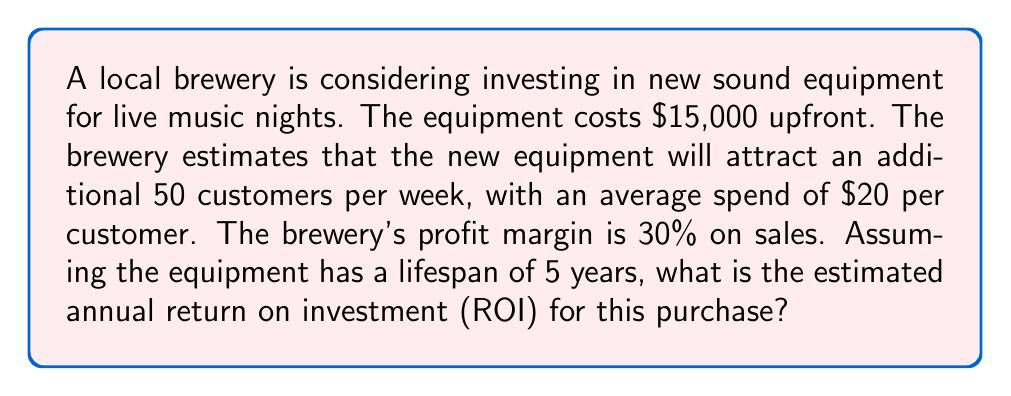Can you answer this question? To calculate the annual ROI, we need to follow these steps:

1. Calculate the additional annual revenue:
   $$ \text{Additional Weekly Revenue} = 50 \text{ customers} \times \$20 = \$1,000 $$
   $$ \text{Additional Annual Revenue} = \$1,000 \times 52 \text{ weeks} = \$52,000 $$

2. Calculate the annual profit from the additional revenue:
   $$ \text{Annual Profit} = \$52,000 \times 30\% = \$15,600 $$

3. Calculate the average annual investment:
   Since the equipment costs $15,000 and lasts for 5 years, the average annual investment is:
   $$ \text{Average Annual Investment} = \frac{\$15,000}{5 \text{ years}} = \$3,000 $$

4. Calculate the annual ROI:
   The ROI formula is: $$ \text{ROI} = \frac{\text{Gain from Investment} - \text{Cost of Investment}}{\text{Cost of Investment}} \times 100\% $$
   
   In this case:
   $$ \text{Annual ROI} = \frac{\$15,600 - \$3,000}{\$3,000} \times 100\% $$
   $$ = \frac{\$12,600}{\$3,000} \times 100\% $$
   $$ = 4.2 \times 100\% = 420\% $$
Answer: The estimated annual return on investment (ROI) for purchasing the new sound equipment is 420%. 